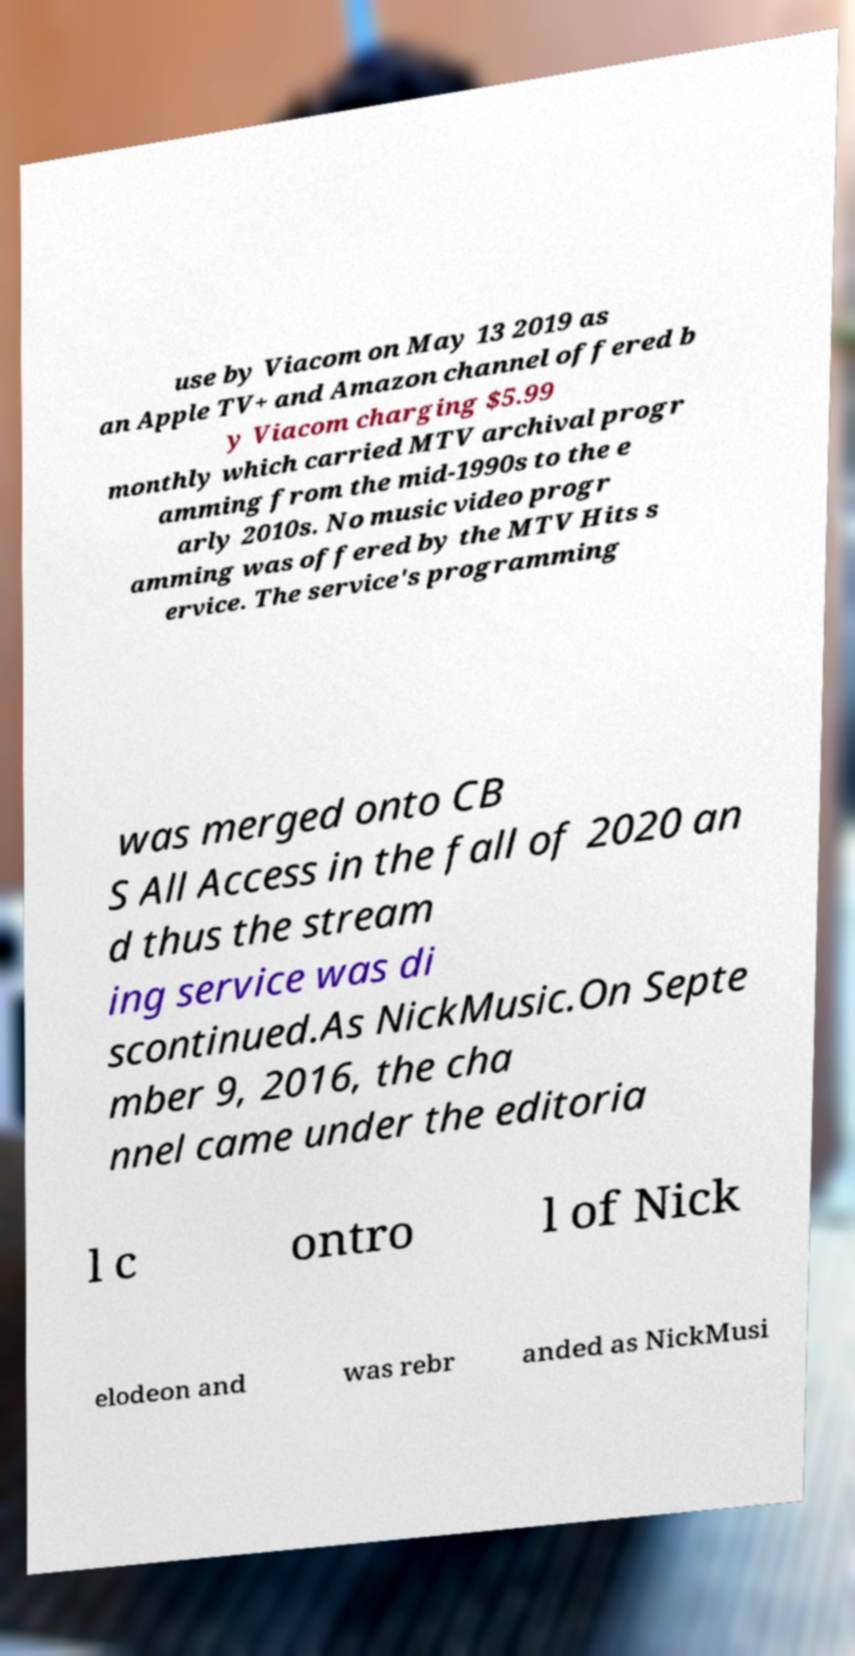Please identify and transcribe the text found in this image. use by Viacom on May 13 2019 as an Apple TV+ and Amazon channel offered b y Viacom charging $5.99 monthly which carried MTV archival progr amming from the mid-1990s to the e arly 2010s. No music video progr amming was offered by the MTV Hits s ervice. The service's programming was merged onto CB S All Access in the fall of 2020 an d thus the stream ing service was di scontinued.As NickMusic.On Septe mber 9, 2016, the cha nnel came under the editoria l c ontro l of Nick elodeon and was rebr anded as NickMusi 